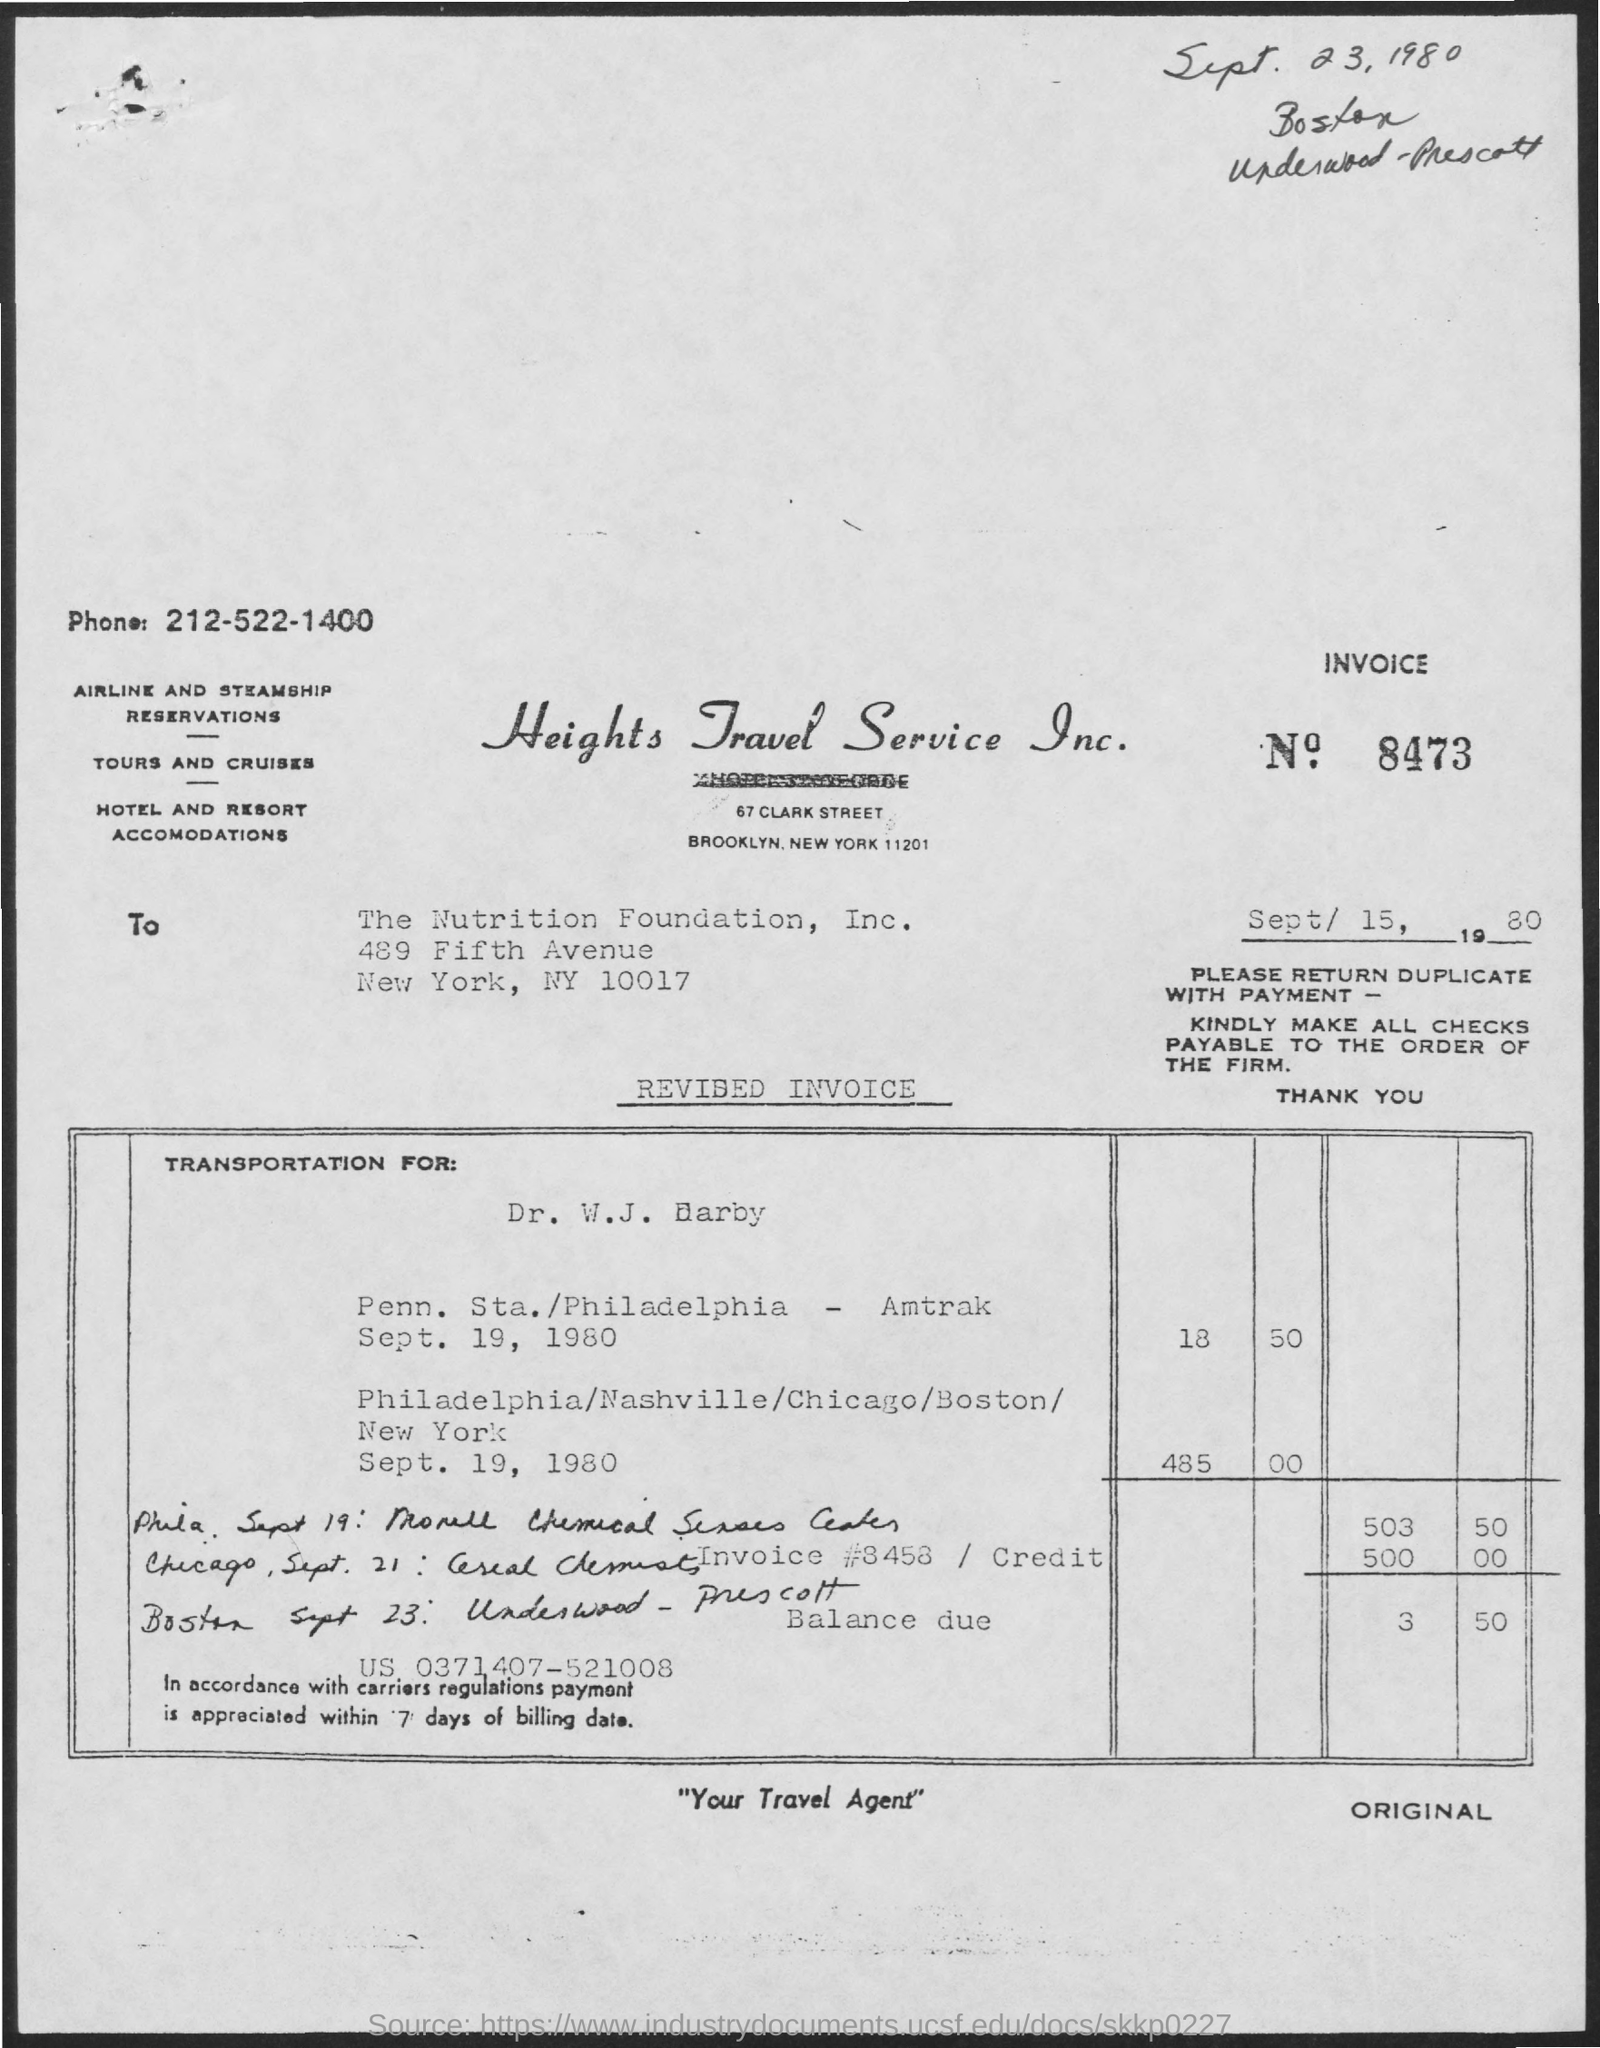What is the phone number of heights travel service inc. ?
Your answer should be compact. 212-522-1400. What is the invoice number?
Ensure brevity in your answer.  8473. What is the tagline of heights travel service inc. in quotations below?
Give a very brief answer. "Your travel agent". 